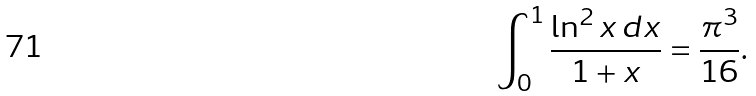Convert formula to latex. <formula><loc_0><loc_0><loc_500><loc_500>\int _ { 0 } ^ { 1 } \frac { \ln ^ { 2 } x \, d x } { 1 + x } = \frac { \pi ^ { 3 } } { 1 6 } .</formula> 